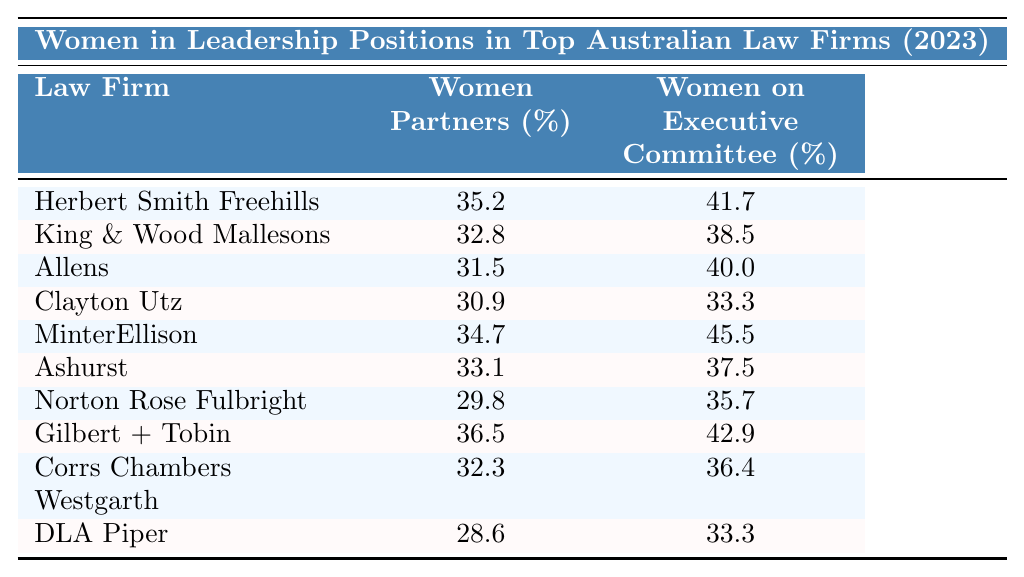What is the percentage of women partners in Herbert Smith Freehills? The table shows that the percentage of women partners in Herbert Smith Freehills is 35.2%.
Answer: 35.2% Which law firm has the highest percentage of women on the executive committee? By examining the table, Gilbert + Tobin has the highest percentage of women on the executive committee at 42.9%.
Answer: Gilbert + Tobin What is the average percentage of women partners across all listed law firms? To find the average, we sum the percentages of women partners (35.2 + 32.8 + 31.5 + 30.9 + 34.7 + 33.1 + 29.8 + 36.5 + 32.3 + 28.6 =  354.4) and divide by the number of firms (10), resulting in an average of 35.44%.
Answer: 35.44% Is the percentage of women partners in DLA Piper greater than 30%? The table indicates that DLA Piper has a percentage of women partners at 28.6%, which is less than 30%.
Answer: No What is the difference between the percentage of women partners at Clayton Utz and MinterEllison? Clayton Utz has a percentage of women partners at 30.9% and MinterEllison at 34.7%. The difference is calculated as 34.7 - 30.9 = 3.8%.
Answer: 3.8% How many law firms have a percentage of women partners greater than 32%? By checking the table, the firms with percentages greater than 32% are Herbert Smith Freehills, King & Wood Mallesons, MinterEllison, Ashurst, and Gilbert + Tobin, totaling 5 firms.
Answer: 5 What percentage of women partners are there in the lowest-ranking law firm? According to the table, DLA Piper ranks the lowest with a percentage of women partners at 28.6%.
Answer: 28.6% If we combine the percentages of women partners and women on the executive committee for Allens, what is the total? The percentages for Allens are 31.5% (women partners) and 40.0% (women on the executive committee). The total is 31.5 + 40.0 = 71.5%.
Answer: 71.5% Which law firm has a higher percentage of women on the executive committee: Gilber + Tobin or MinterEllison? Gilbert + Tobin has 42.9% while MinterEllison has 45.5%. Thus, MinterEllison has a higher percentage.
Answer: MinterEllison Are there more firms with a percentage of women partners below 30% than above? The table shows that there is only one firm (DLA Piper) below 30%, and nine firms above 30%. Therefore, there are more firms above 30%.
Answer: No What is the median percentage of women on the executive committee across all firms? Arranging the percentages (33.3, 33.3, 35.7, 36.4, 37.5, 38.5, 41.7, 40.0, 42.9, 45.5) and finding the median (the average of the 5th and 6th values) gives (37.5 + 38.5)/2 = 38.0%.
Answer: 38.0% 